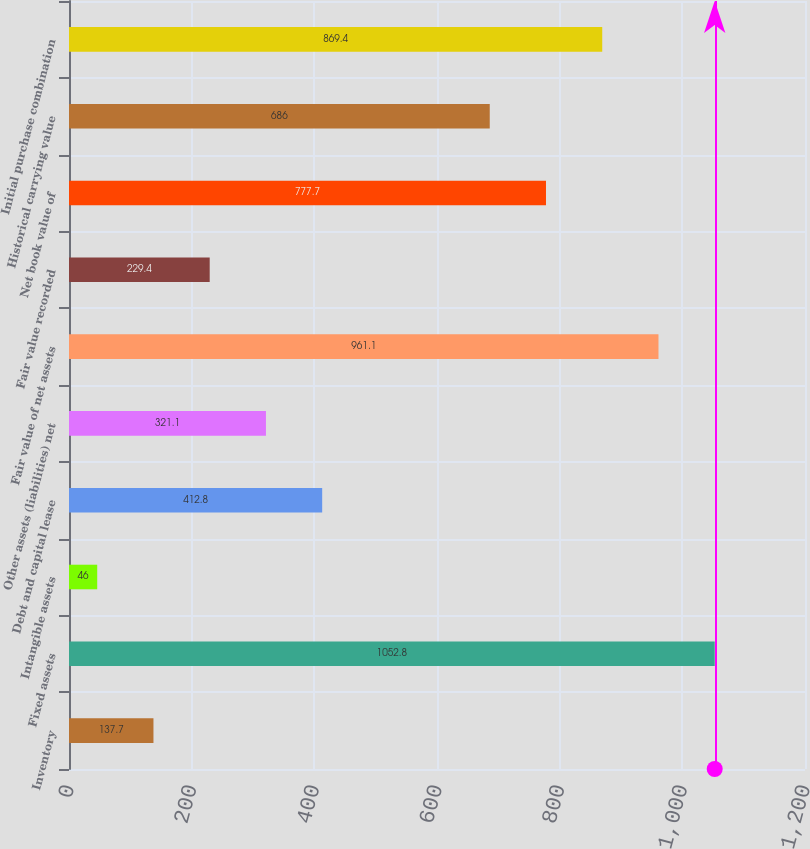Convert chart. <chart><loc_0><loc_0><loc_500><loc_500><bar_chart><fcel>Inventory<fcel>Fixed assets<fcel>Intangible assets<fcel>Debt and capital lease<fcel>Other assets (liabilities) net<fcel>Fair value of net assets<fcel>Fair value recorded<fcel>Net book value of<fcel>Historical carrying value<fcel>Initial purchase combination<nl><fcel>137.7<fcel>1052.8<fcel>46<fcel>412.8<fcel>321.1<fcel>961.1<fcel>229.4<fcel>777.7<fcel>686<fcel>869.4<nl></chart> 